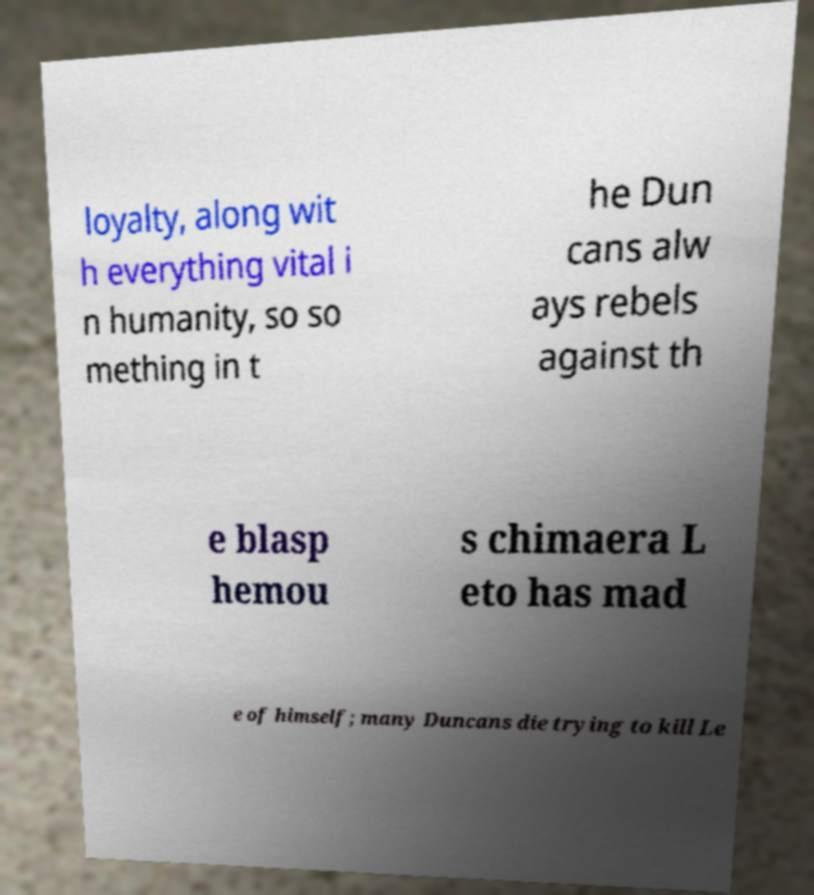Please identify and transcribe the text found in this image. loyalty, along wit h everything vital i n humanity, so so mething in t he Dun cans alw ays rebels against th e blasp hemou s chimaera L eto has mad e of himself; many Duncans die trying to kill Le 